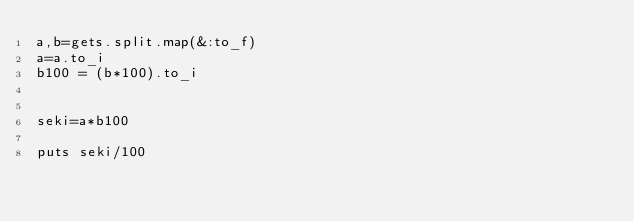Convert code to text. <code><loc_0><loc_0><loc_500><loc_500><_Ruby_>a,b=gets.split.map(&:to_f)
a=a.to_i
b100 = (b*100).to_i


seki=a*b100

puts seki/100
</code> 